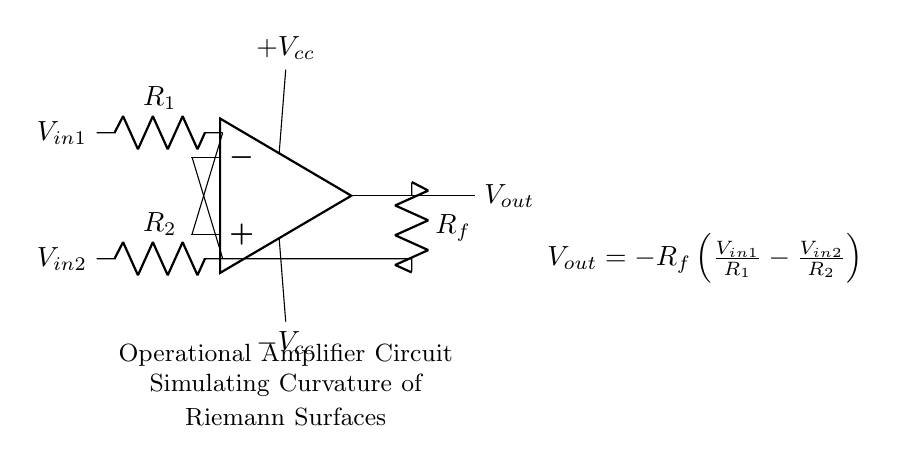What is the type of operational amplifier used in this circuit? The circuit diagram depicts a generic operational amplifier, indicated by the symbol used (op amp). It is designed to amplify the difference between the two input voltages.
Answer: operational amplifier What is the feedback resistor in this circuit? Based on the diagram, the feedback resistor is labeled Rf, shown connecting the output to the inverting input of the op amp. This configuration is characteristic of a feedback loop in an amplifier circuit.
Answer: Rf What is the relationship between Vout and Vin1 and Vin2 in this circuit? The equation provided in the diagram indicates that Vout is a function of Vin1 and Vin2. Specifically, Vout is equal to negative Rf multiplied by the difference in the ratios of Vin1 to R1 and Vin2 to R2. This relationship reflects how the circuit amplifies and processes the input voltages.
Answer: Vout = -Rf(Vin1/R1 - Vin2/R2) What are the input voltages labeled in the circuit? The circuit indicates two input voltages: Vin1 and Vin2. These references are labeled appropriately on the left side of the op amp symbol, corresponding to the non-inverting and inverting inputs.
Answer: Vin1 and Vin2 What does R2 represent in the context of this circuit? In the circuit, R2 is a resistor connected to the inverting input of the op amp, defining a part of the input stage responsible for controlling the contribution of voltage Vin2 to the output. The resistance value affects the gain and operation of the amplifier circuit by setting the input impedance.
Answer: R2 How many resistors are in the circuit? The circuit contains three resistors: R1, R2, and Rf. Each resistor serves a specific function in the operation of the op amp, contributing to the overall gain and feedback in the amplifier configuration.
Answer: three 